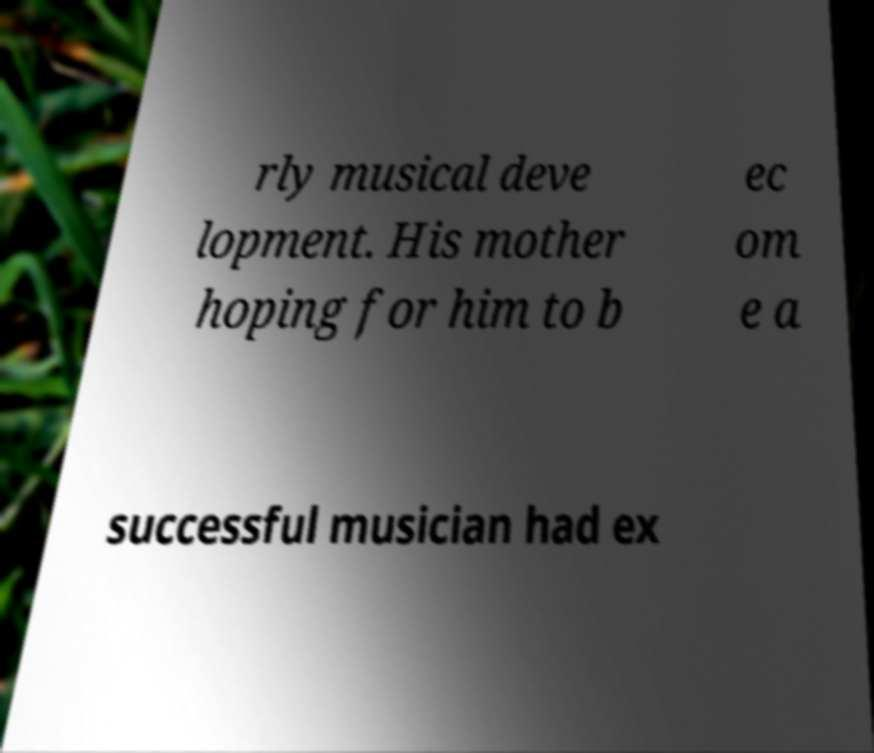I need the written content from this picture converted into text. Can you do that? rly musical deve lopment. His mother hoping for him to b ec om e a successful musician had ex 